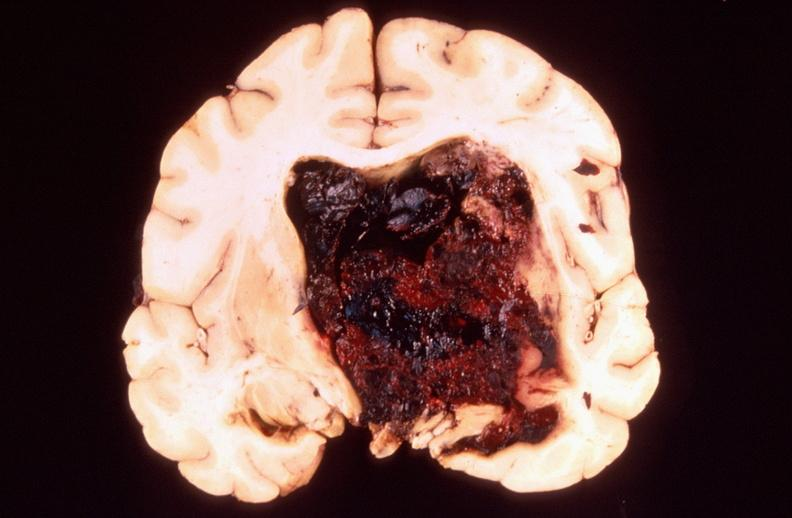s cytomegalovirus present?
Answer the question using a single word or phrase. No 